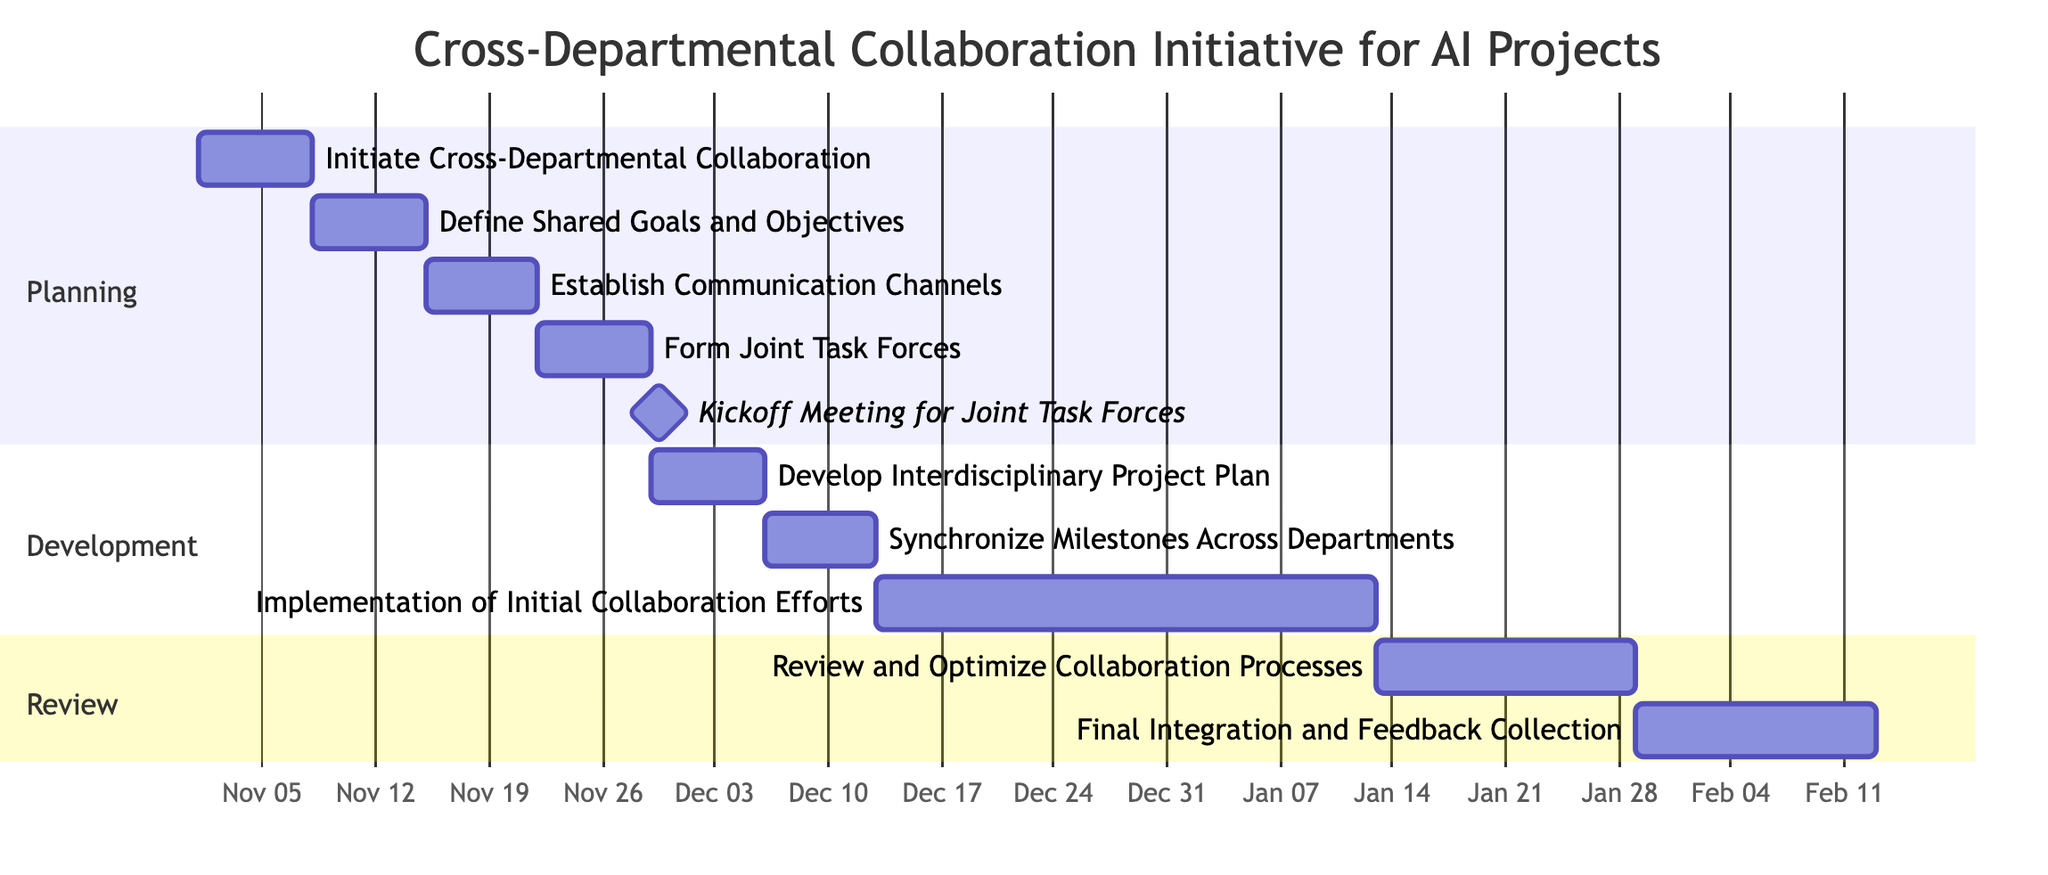What is the duration of the "Initiate Cross-Departmental Collaboration" task? The task begins on November 1, 2023, and ends on November 7, 2023. Therefore, the duration is 7 days.
Answer: 7 days What task follows directly after the "Establish Communication Channels"? The task that follows directly after "Establish Communication Channels" is "Form Joint Task Forces." Dependencies show that it relies on the completion of the previous task.
Answer: Form Joint Task Forces How many tasks are listed in the "Planning" section? The "Planning" section contains four tasks. By counting the tasks visually or through the data, we find: "Initiate Cross-Departmental Collaboration," "Define Shared Goals and Objectives," "Establish Communication Channels," and "Form Joint Task Forces."
Answer: 4 What is the end date of the "Final Integration and Feedback Collection" task? This task starts on February 1, 2024, and ends on February 15, 2024. The end date can be found in the task details provided.
Answer: February 15, 2024 What is the total duration for the "Implementation of Initial Collaboration Efforts"? This task starts on December 16, 2023, and ends on January 15, 2024, providing a total duration of 31 days.
Answer: 31 days How is the "Kickoff Meeting for Joint Task Forces" classified in the diagram? The "Kickoff Meeting for Joint Task Forces" is classified as a milestone, which indicates that it marks a significant point in the project timeline rather than having a duration.
Answer: milestone Which task has the longest duration in the entire project? The task with the longest duration is the "Implementation of Initial Collaboration Efforts," lasting for 31 days, as seen from its start and end dates.
Answer: Implementation of Initial Collaboration Efforts What section does the "Review and Optimize Collaboration Processes" task belong to? This task is under the "Review" section, which can be identified by its placement in the diagram alongside other tasks pertaining to evaluation and feedback.
Answer: Review What task is dependent on the "Define Shared Goals and Objectives"? The task that is dependent on "Define Shared Goals and Objectives" is "Establish Communication Channels." The flow of dependencies indicates this relationship.
Answer: Establish Communication Channels 